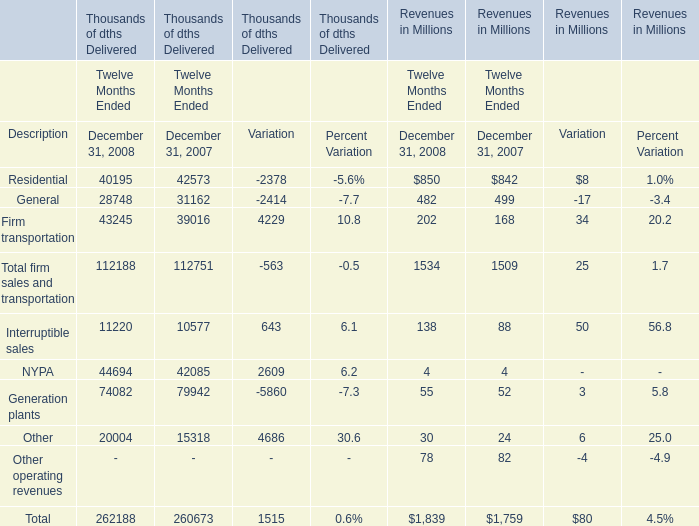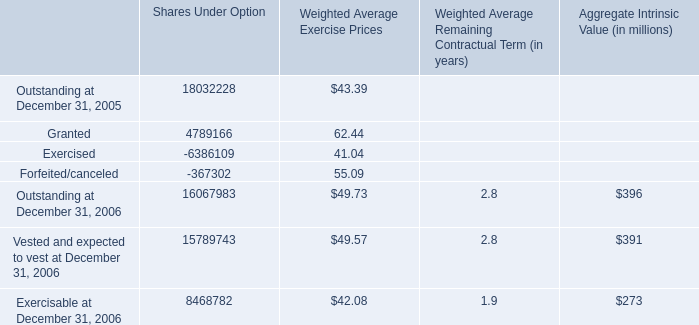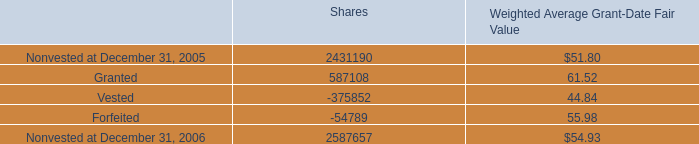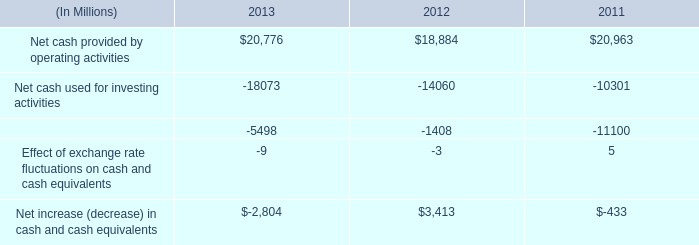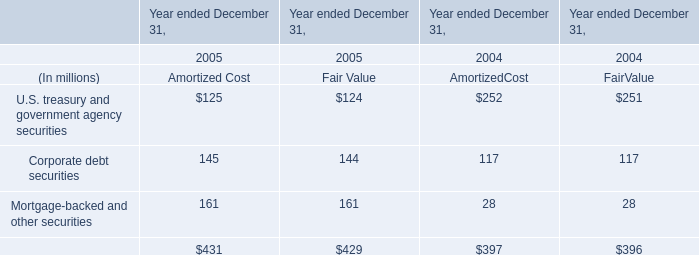What is the sum of General of Revenues in Millions in 2007 and Corporate debt securities of Fair Value in 2005? (in million) 
Computations: (499 + 144)
Answer: 643.0. 